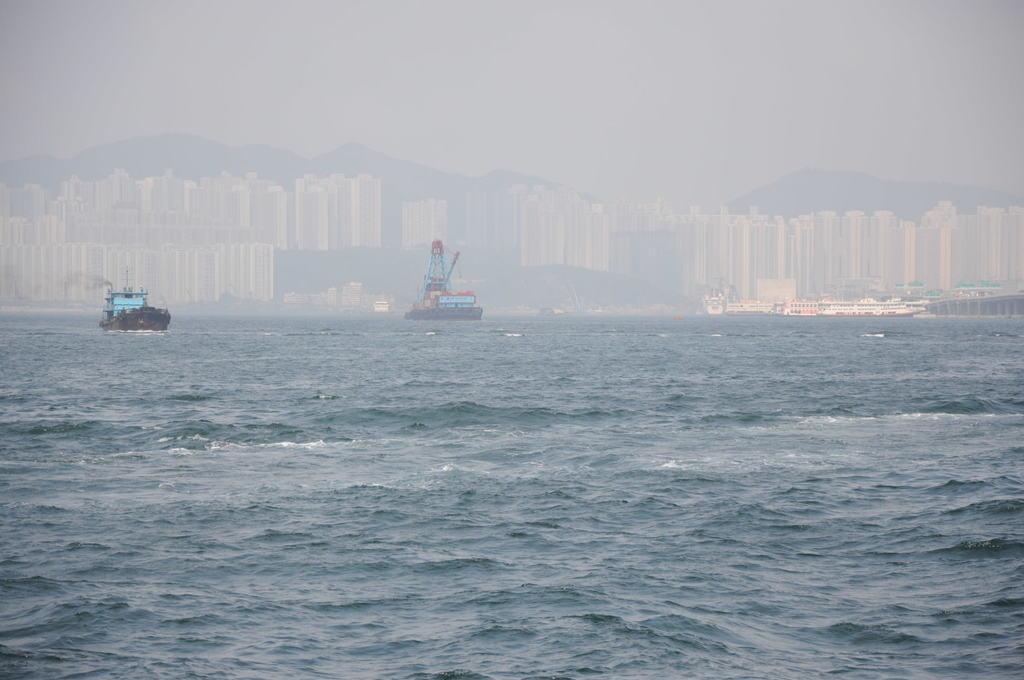Describe this image in one or two sentences. In this image I see few boats on the water. In the background I see the buildings, mountains and the sky. 